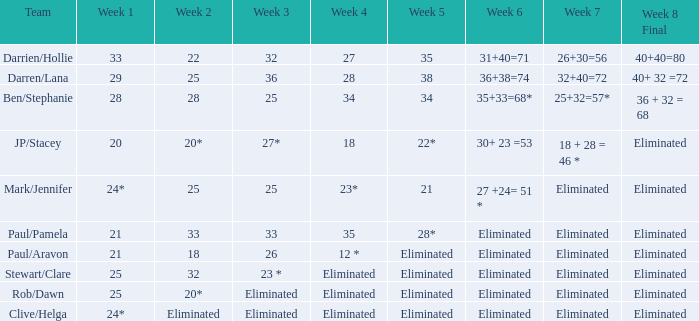Identify the third week for mark and jennifer's team. 25.0. 